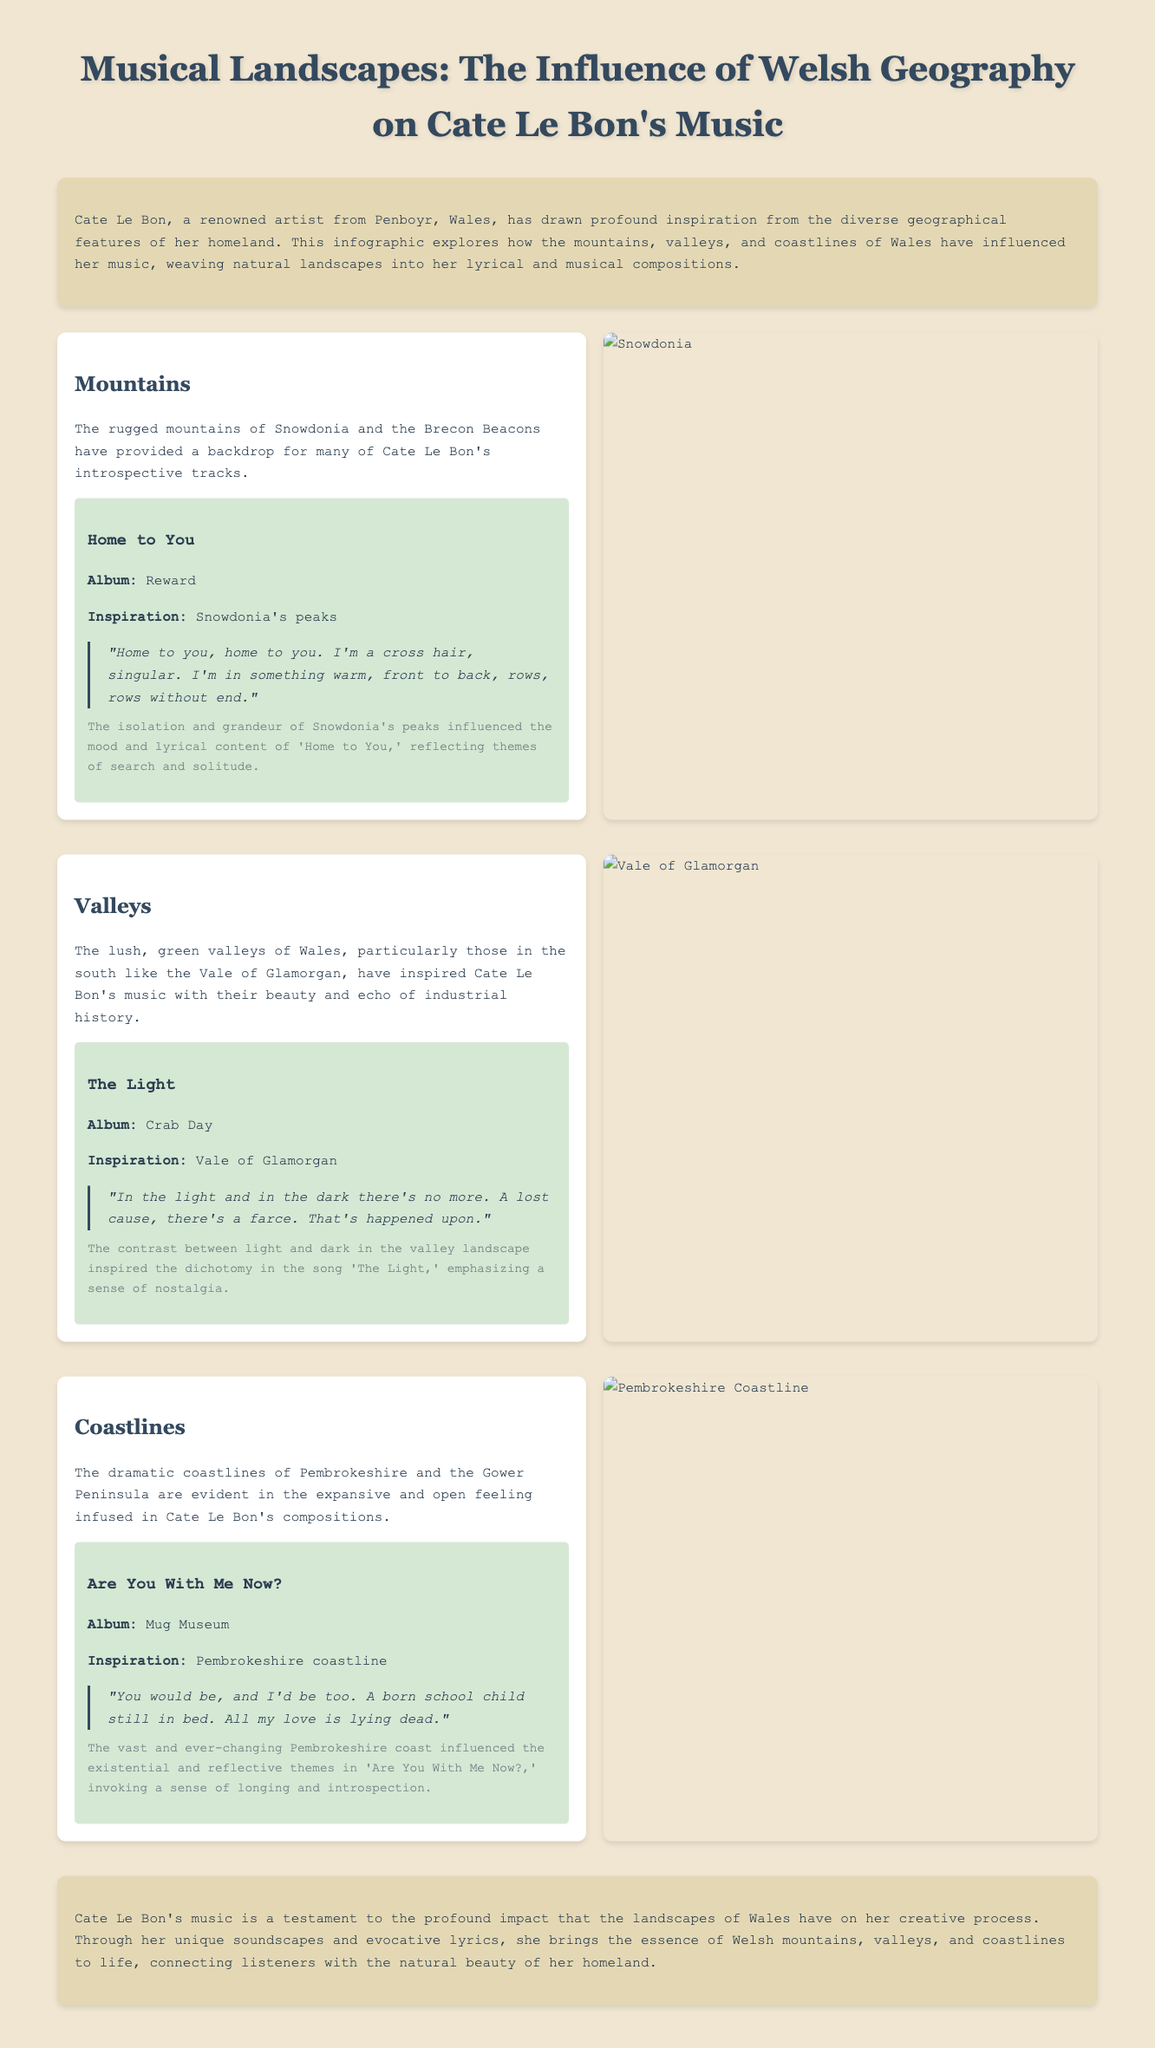What is the title of the infographic? The title is stated at the top of the document, emphasizing the theme of Welsh geography and its influence on music.
Answer: Musical Landscapes: The Influence of Welsh Geography on Cate Le Bon's Music Which album features the song "Home to You"? The album is mentioned in the song section related to mountains, indicating its source.
Answer: Reward What geographical feature inspired the song "The Light"? The inspiration is clearly specified in the section about valleys, linked to the specific place.
Answer: Vale of Glamorgan How does the document categorize Welsh geography? The categories are explicitly outlined with headings in the sections discussing their influence on music.
Answer: Mountains, Valleys, Coastlines What themes are reflected in "Are You With Me Now?" The document describes the themes that arise from the geographical inspiration of the song, which helps convey its deeper meaning.
Answer: Longing and introspection What is the source of inspiration for the song "The Light"? The source is mentioned directly in the section, detailing what landscape influenced the song's creation.
Answer: Vale of Glamorgan Which artist is the focus of this infographic? The artist is mentioned in the introduction and throughout the document, emphasizing her connection to the landscapes described.
Answer: Cate Le Bon What type of landscape are the Pembrokeshire and Gower Peninsula associated with? The document specifically states the geographical feature associated with these areas, catering to the overarching theme of the infographic.
Answer: Coastlines 